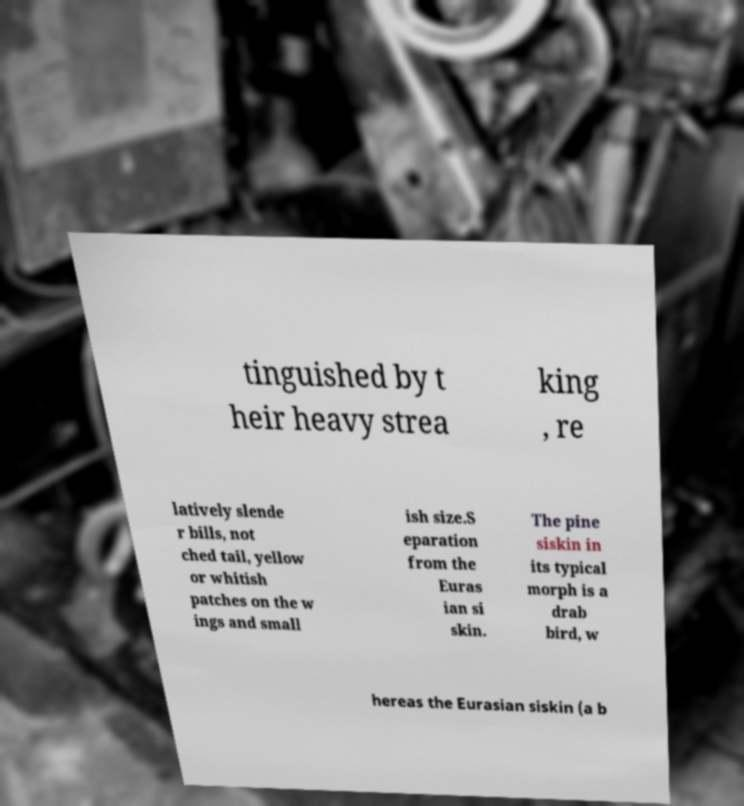For documentation purposes, I need the text within this image transcribed. Could you provide that? tinguished by t heir heavy strea king , re latively slende r bills, not ched tail, yellow or whitish patches on the w ings and small ish size.S eparation from the Euras ian si skin. The pine siskin in its typical morph is a drab bird, w hereas the Eurasian siskin (a b 